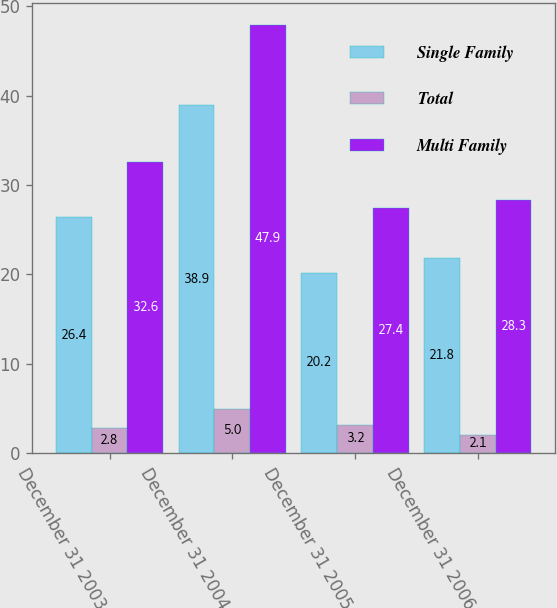Convert chart to OTSL. <chart><loc_0><loc_0><loc_500><loc_500><stacked_bar_chart><ecel><fcel>December 31 2003<fcel>December 31 2004<fcel>December 31 2005<fcel>December 31 2006<nl><fcel>Single Family<fcel>26.4<fcel>38.9<fcel>20.2<fcel>21.8<nl><fcel>Total<fcel>2.8<fcel>5<fcel>3.2<fcel>2.1<nl><fcel>Multi Family<fcel>32.6<fcel>47.9<fcel>27.4<fcel>28.3<nl></chart> 